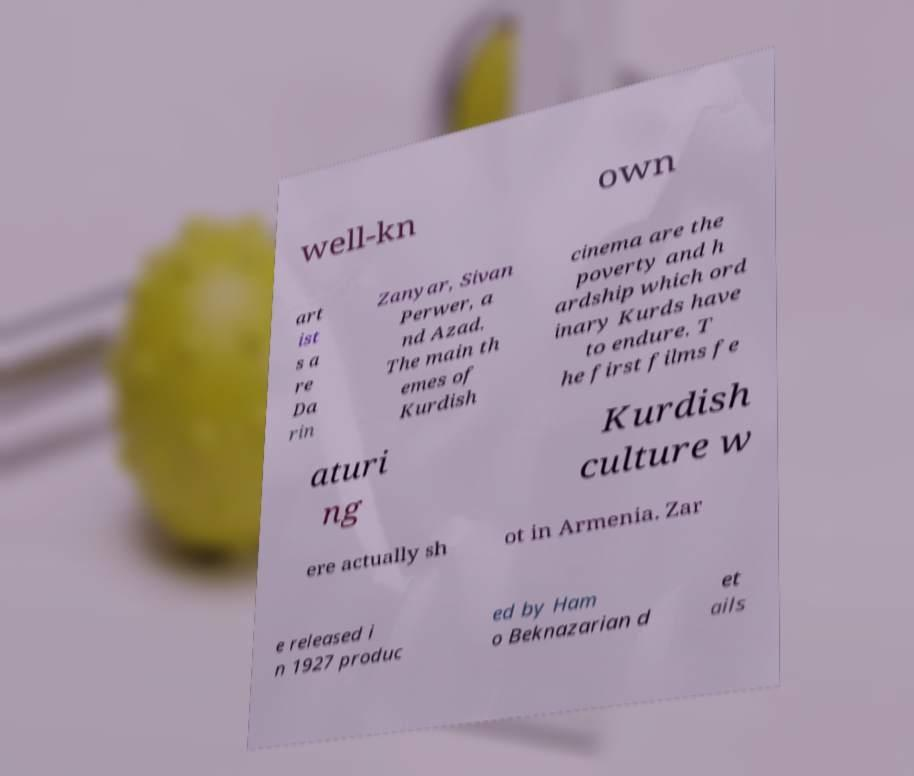Could you assist in decoding the text presented in this image and type it out clearly? well-kn own art ist s a re Da rin Zanyar, Sivan Perwer, a nd Azad. The main th emes of Kurdish cinema are the poverty and h ardship which ord inary Kurds have to endure. T he first films fe aturi ng Kurdish culture w ere actually sh ot in Armenia. Zar e released i n 1927 produc ed by Ham o Beknazarian d et ails 